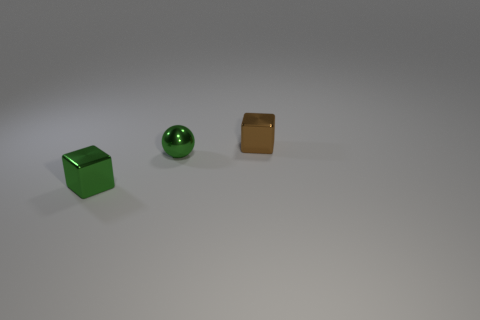Add 2 tiny blocks. How many objects exist? 5 Subtract 1 blocks. How many blocks are left? 1 Subtract all balls. How many objects are left? 2 Subtract all green balls. How many brown blocks are left? 1 Subtract 0 purple cylinders. How many objects are left? 3 Subtract all purple cubes. Subtract all cyan cylinders. How many cubes are left? 2 Subtract all green blocks. Subtract all tiny brown things. How many objects are left? 1 Add 3 blocks. How many blocks are left? 5 Add 1 brown metal things. How many brown metal things exist? 2 